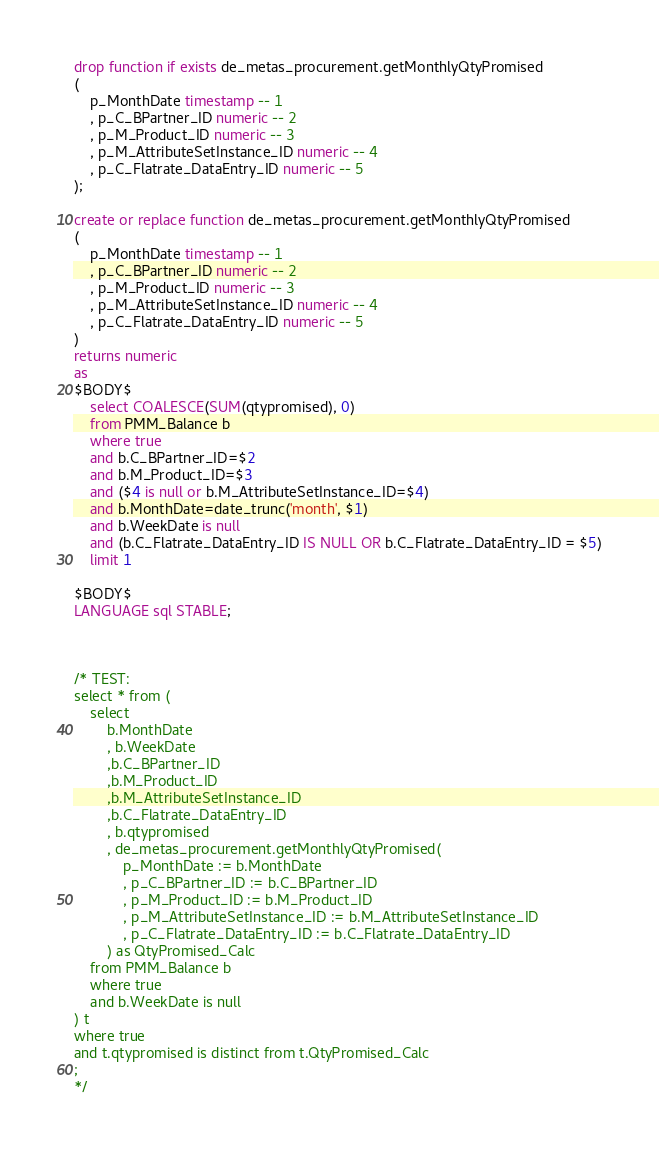<code> <loc_0><loc_0><loc_500><loc_500><_SQL_>drop function if exists de_metas_procurement.getMonthlyQtyPromised
(
	p_MonthDate timestamp -- 1
	, p_C_BPartner_ID numeric -- 2
	, p_M_Product_ID numeric -- 3
	, p_M_AttributeSetInstance_ID numeric -- 4
	, p_C_Flatrate_DataEntry_ID numeric -- 5
);

create or replace function de_metas_procurement.getMonthlyQtyPromised
(
	p_MonthDate timestamp -- 1
	, p_C_BPartner_ID numeric -- 2
	, p_M_Product_ID numeric -- 3
	, p_M_AttributeSetInstance_ID numeric -- 4
	, p_C_Flatrate_DataEntry_ID numeric -- 5
)
returns numeric
as
$BODY$
	select COALESCE(SUM(qtypromised), 0)
	from PMM_Balance b
	where true
	and b.C_BPartner_ID=$2
	and b.M_Product_ID=$3
	and ($4 is null or b.M_AttributeSetInstance_ID=$4)
	and b.MonthDate=date_trunc('month', $1)
	and b.WeekDate is null
	and (b.C_Flatrate_DataEntry_ID IS NULL OR b.C_Flatrate_DataEntry_ID = $5)
	limit 1

$BODY$
LANGUAGE sql STABLE;



/* TEST:
select * from (
	select
		b.MonthDate
		, b.WeekDate
		,b.C_BPartner_ID
		,b.M_Product_ID
		,b.M_AttributeSetInstance_ID
		,b.C_Flatrate_DataEntry_ID
		, b.qtypromised
		, de_metas_procurement.getMonthlyQtyPromised(
			p_MonthDate := b.MonthDate
			, p_C_BPartner_ID := b.C_BPartner_ID
			, p_M_Product_ID := b.M_Product_ID
			, p_M_AttributeSetInstance_ID := b.M_AttributeSetInstance_ID
			, p_C_Flatrate_DataEntry_ID := b.C_Flatrate_DataEntry_ID
		) as QtyPromised_Calc
	from PMM_Balance b
	where true
	and b.WeekDate is null
) t
where true
and t.qtypromised is distinct from t.QtyPromised_Calc
;
*/
</code> 